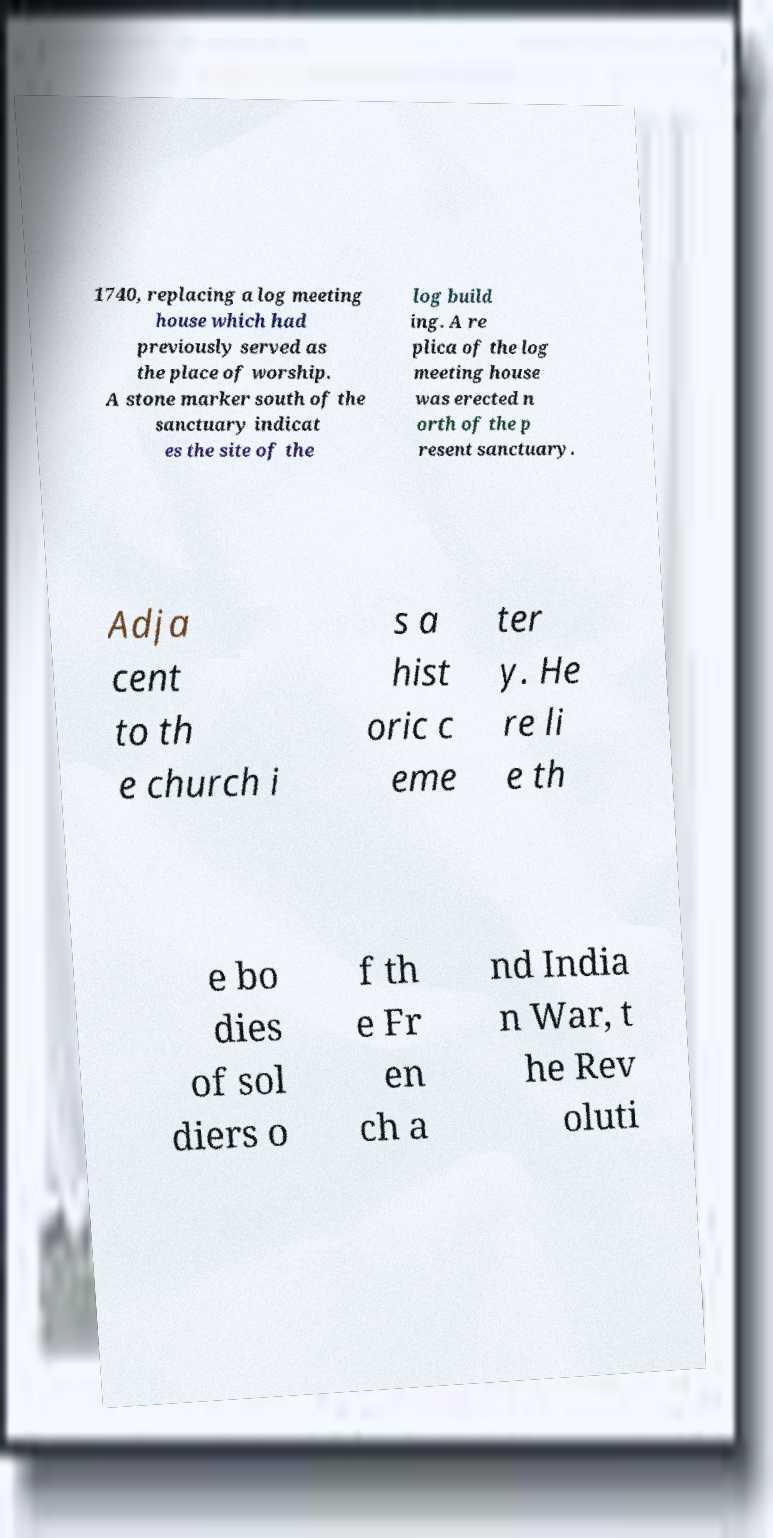Could you extract and type out the text from this image? 1740, replacing a log meeting house which had previously served as the place of worship. A stone marker south of the sanctuary indicat es the site of the log build ing. A re plica of the log meeting house was erected n orth of the p resent sanctuary. Adja cent to th e church i s a hist oric c eme ter y. He re li e th e bo dies of sol diers o f th e Fr en ch a nd India n War, t he Rev oluti 